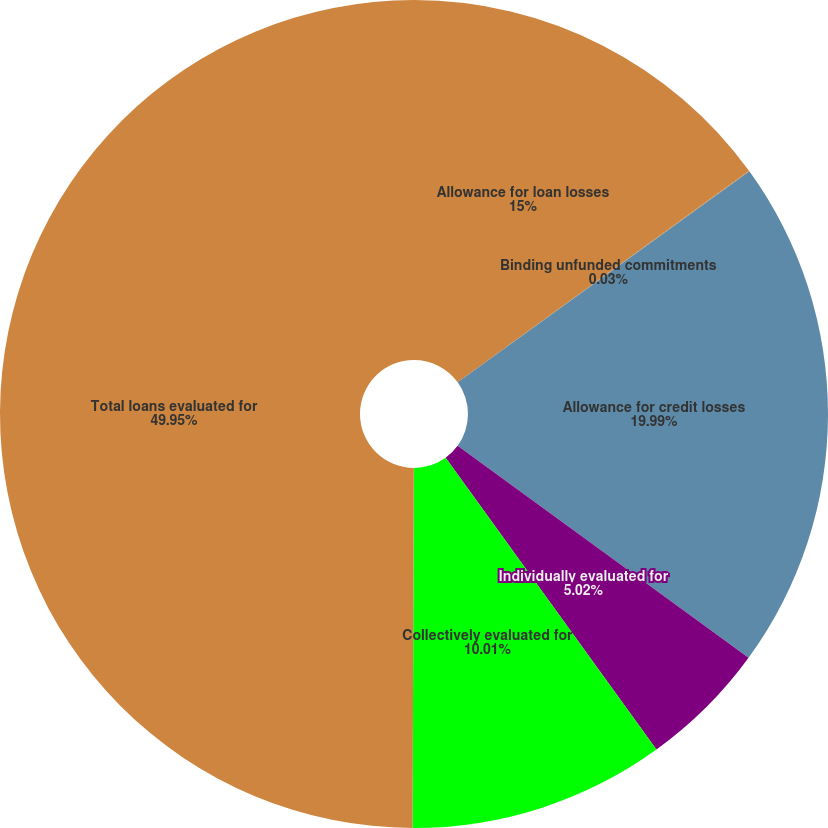<chart> <loc_0><loc_0><loc_500><loc_500><pie_chart><fcel>Allowance for loan losses<fcel>Binding unfunded commitments<fcel>Allowance for credit losses<fcel>Individually evaluated for<fcel>Collectively evaluated for<fcel>Total loans evaluated for<nl><fcel>15.0%<fcel>0.03%<fcel>19.99%<fcel>5.02%<fcel>10.01%<fcel>49.94%<nl></chart> 